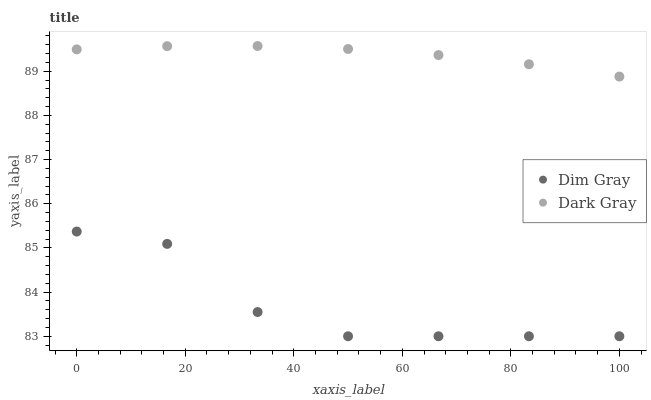Does Dim Gray have the minimum area under the curve?
Answer yes or no. Yes. Does Dark Gray have the maximum area under the curve?
Answer yes or no. Yes. Does Dim Gray have the maximum area under the curve?
Answer yes or no. No. Is Dark Gray the smoothest?
Answer yes or no. Yes. Is Dim Gray the roughest?
Answer yes or no. Yes. Is Dim Gray the smoothest?
Answer yes or no. No. Does Dim Gray have the lowest value?
Answer yes or no. Yes. Does Dark Gray have the highest value?
Answer yes or no. Yes. Does Dim Gray have the highest value?
Answer yes or no. No. Is Dim Gray less than Dark Gray?
Answer yes or no. Yes. Is Dark Gray greater than Dim Gray?
Answer yes or no. Yes. Does Dim Gray intersect Dark Gray?
Answer yes or no. No. 